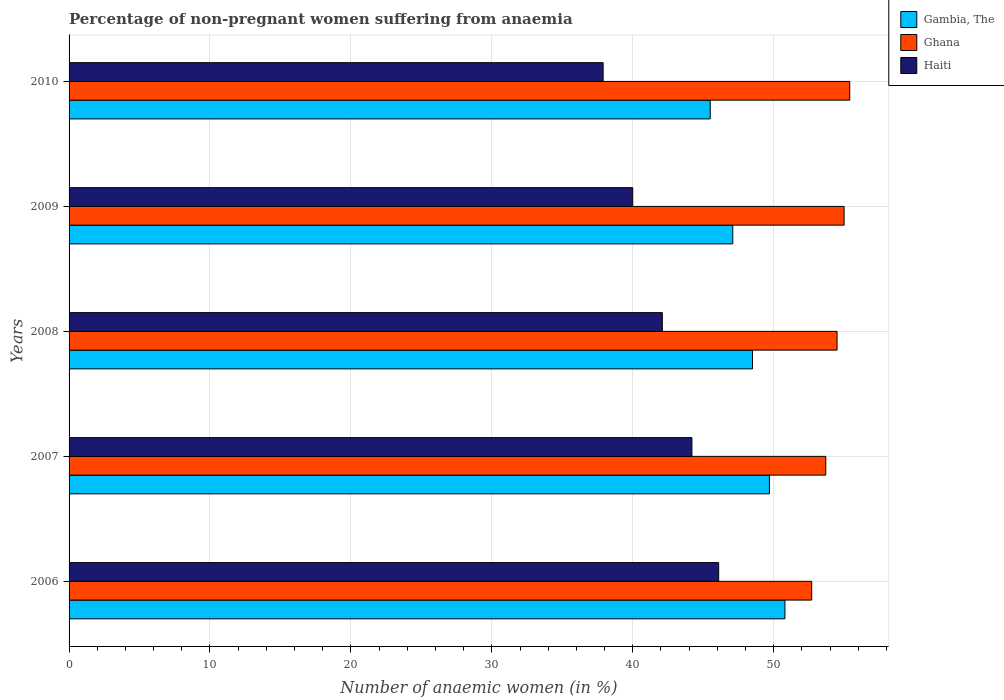How many groups of bars are there?
Ensure brevity in your answer.  5. How many bars are there on the 1st tick from the top?
Provide a succinct answer. 3. In how many cases, is the number of bars for a given year not equal to the number of legend labels?
Your answer should be compact. 0. What is the percentage of non-pregnant women suffering from anaemia in Gambia, The in 2007?
Provide a succinct answer. 49.7. Across all years, what is the maximum percentage of non-pregnant women suffering from anaemia in Gambia, The?
Keep it short and to the point. 50.8. Across all years, what is the minimum percentage of non-pregnant women suffering from anaemia in Ghana?
Provide a succinct answer. 52.7. In which year was the percentage of non-pregnant women suffering from anaemia in Ghana minimum?
Give a very brief answer. 2006. What is the total percentage of non-pregnant women suffering from anaemia in Haiti in the graph?
Offer a terse response. 210.3. What is the difference between the percentage of non-pregnant women suffering from anaemia in Haiti in 2008 and the percentage of non-pregnant women suffering from anaemia in Ghana in 2007?
Your answer should be very brief. -11.6. What is the average percentage of non-pregnant women suffering from anaemia in Gambia, The per year?
Give a very brief answer. 48.32. In the year 2006, what is the difference between the percentage of non-pregnant women suffering from anaemia in Ghana and percentage of non-pregnant women suffering from anaemia in Gambia, The?
Keep it short and to the point. 1.9. In how many years, is the percentage of non-pregnant women suffering from anaemia in Gambia, The greater than 12 %?
Keep it short and to the point. 5. What is the ratio of the percentage of non-pregnant women suffering from anaemia in Ghana in 2007 to that in 2008?
Keep it short and to the point. 0.99. Is the percentage of non-pregnant women suffering from anaemia in Ghana in 2009 less than that in 2010?
Your response must be concise. Yes. Is the difference between the percentage of non-pregnant women suffering from anaemia in Ghana in 2006 and 2007 greater than the difference between the percentage of non-pregnant women suffering from anaemia in Gambia, The in 2006 and 2007?
Keep it short and to the point. No. What is the difference between the highest and the second highest percentage of non-pregnant women suffering from anaemia in Ghana?
Ensure brevity in your answer.  0.4. What is the difference between the highest and the lowest percentage of non-pregnant women suffering from anaemia in Gambia, The?
Your answer should be compact. 5.3. What does the 3rd bar from the top in 2006 represents?
Your answer should be very brief. Gambia, The. What does the 2nd bar from the bottom in 2007 represents?
Your answer should be very brief. Ghana. Is it the case that in every year, the sum of the percentage of non-pregnant women suffering from anaemia in Ghana and percentage of non-pregnant women suffering from anaemia in Gambia, The is greater than the percentage of non-pregnant women suffering from anaemia in Haiti?
Ensure brevity in your answer.  Yes. How many years are there in the graph?
Make the answer very short. 5. Does the graph contain any zero values?
Your answer should be compact. No. Where does the legend appear in the graph?
Give a very brief answer. Top right. What is the title of the graph?
Ensure brevity in your answer.  Percentage of non-pregnant women suffering from anaemia. Does "Sub-Saharan Africa (developing only)" appear as one of the legend labels in the graph?
Provide a short and direct response. No. What is the label or title of the X-axis?
Your answer should be very brief. Number of anaemic women (in %). What is the label or title of the Y-axis?
Provide a short and direct response. Years. What is the Number of anaemic women (in %) in Gambia, The in 2006?
Your response must be concise. 50.8. What is the Number of anaemic women (in %) in Ghana in 2006?
Ensure brevity in your answer.  52.7. What is the Number of anaemic women (in %) of Haiti in 2006?
Provide a succinct answer. 46.1. What is the Number of anaemic women (in %) in Gambia, The in 2007?
Provide a short and direct response. 49.7. What is the Number of anaemic women (in %) in Ghana in 2007?
Your response must be concise. 53.7. What is the Number of anaemic women (in %) of Haiti in 2007?
Provide a succinct answer. 44.2. What is the Number of anaemic women (in %) in Gambia, The in 2008?
Your response must be concise. 48.5. What is the Number of anaemic women (in %) of Ghana in 2008?
Ensure brevity in your answer.  54.5. What is the Number of anaemic women (in %) of Haiti in 2008?
Your response must be concise. 42.1. What is the Number of anaemic women (in %) in Gambia, The in 2009?
Keep it short and to the point. 47.1. What is the Number of anaemic women (in %) in Ghana in 2009?
Ensure brevity in your answer.  55. What is the Number of anaemic women (in %) of Gambia, The in 2010?
Your response must be concise. 45.5. What is the Number of anaemic women (in %) in Ghana in 2010?
Give a very brief answer. 55.4. What is the Number of anaemic women (in %) in Haiti in 2010?
Your answer should be very brief. 37.9. Across all years, what is the maximum Number of anaemic women (in %) of Gambia, The?
Offer a very short reply. 50.8. Across all years, what is the maximum Number of anaemic women (in %) in Ghana?
Give a very brief answer. 55.4. Across all years, what is the maximum Number of anaemic women (in %) in Haiti?
Make the answer very short. 46.1. Across all years, what is the minimum Number of anaemic women (in %) in Gambia, The?
Provide a short and direct response. 45.5. Across all years, what is the minimum Number of anaemic women (in %) of Ghana?
Provide a succinct answer. 52.7. Across all years, what is the minimum Number of anaemic women (in %) of Haiti?
Provide a succinct answer. 37.9. What is the total Number of anaemic women (in %) of Gambia, The in the graph?
Provide a succinct answer. 241.6. What is the total Number of anaemic women (in %) of Ghana in the graph?
Offer a terse response. 271.3. What is the total Number of anaemic women (in %) in Haiti in the graph?
Offer a terse response. 210.3. What is the difference between the Number of anaemic women (in %) in Gambia, The in 2006 and that in 2007?
Make the answer very short. 1.1. What is the difference between the Number of anaemic women (in %) in Gambia, The in 2006 and that in 2008?
Keep it short and to the point. 2.3. What is the difference between the Number of anaemic women (in %) of Ghana in 2007 and that in 2008?
Offer a terse response. -0.8. What is the difference between the Number of anaemic women (in %) of Gambia, The in 2007 and that in 2009?
Keep it short and to the point. 2.6. What is the difference between the Number of anaemic women (in %) in Gambia, The in 2007 and that in 2010?
Offer a terse response. 4.2. What is the difference between the Number of anaemic women (in %) in Ghana in 2007 and that in 2010?
Keep it short and to the point. -1.7. What is the difference between the Number of anaemic women (in %) of Ghana in 2008 and that in 2010?
Make the answer very short. -0.9. What is the difference between the Number of anaemic women (in %) of Gambia, The in 2009 and that in 2010?
Keep it short and to the point. 1.6. What is the difference between the Number of anaemic women (in %) of Gambia, The in 2006 and the Number of anaemic women (in %) of Haiti in 2007?
Give a very brief answer. 6.6. What is the difference between the Number of anaemic women (in %) in Ghana in 2006 and the Number of anaemic women (in %) in Haiti in 2007?
Provide a succinct answer. 8.5. What is the difference between the Number of anaemic women (in %) in Gambia, The in 2006 and the Number of anaemic women (in %) in Haiti in 2008?
Provide a short and direct response. 8.7. What is the difference between the Number of anaemic women (in %) of Gambia, The in 2006 and the Number of anaemic women (in %) of Ghana in 2010?
Your response must be concise. -4.6. What is the difference between the Number of anaemic women (in %) of Gambia, The in 2006 and the Number of anaemic women (in %) of Haiti in 2010?
Ensure brevity in your answer.  12.9. What is the difference between the Number of anaemic women (in %) in Ghana in 2006 and the Number of anaemic women (in %) in Haiti in 2010?
Ensure brevity in your answer.  14.8. What is the difference between the Number of anaemic women (in %) of Gambia, The in 2007 and the Number of anaemic women (in %) of Ghana in 2008?
Give a very brief answer. -4.8. What is the difference between the Number of anaemic women (in %) of Gambia, The in 2007 and the Number of anaemic women (in %) of Ghana in 2009?
Offer a very short reply. -5.3. What is the difference between the Number of anaemic women (in %) in Gambia, The in 2007 and the Number of anaemic women (in %) in Ghana in 2010?
Give a very brief answer. -5.7. What is the difference between the Number of anaemic women (in %) in Gambia, The in 2008 and the Number of anaemic women (in %) in Haiti in 2010?
Keep it short and to the point. 10.6. What is the difference between the Number of anaemic women (in %) of Ghana in 2009 and the Number of anaemic women (in %) of Haiti in 2010?
Offer a very short reply. 17.1. What is the average Number of anaemic women (in %) in Gambia, The per year?
Ensure brevity in your answer.  48.32. What is the average Number of anaemic women (in %) of Ghana per year?
Your answer should be very brief. 54.26. What is the average Number of anaemic women (in %) of Haiti per year?
Ensure brevity in your answer.  42.06. In the year 2007, what is the difference between the Number of anaemic women (in %) of Gambia, The and Number of anaemic women (in %) of Haiti?
Offer a terse response. 5.5. In the year 2007, what is the difference between the Number of anaemic women (in %) of Ghana and Number of anaemic women (in %) of Haiti?
Your answer should be very brief. 9.5. In the year 2008, what is the difference between the Number of anaemic women (in %) of Ghana and Number of anaemic women (in %) of Haiti?
Offer a terse response. 12.4. In the year 2010, what is the difference between the Number of anaemic women (in %) in Gambia, The and Number of anaemic women (in %) in Ghana?
Offer a very short reply. -9.9. In the year 2010, what is the difference between the Number of anaemic women (in %) of Ghana and Number of anaemic women (in %) of Haiti?
Offer a terse response. 17.5. What is the ratio of the Number of anaemic women (in %) of Gambia, The in 2006 to that in 2007?
Provide a short and direct response. 1.02. What is the ratio of the Number of anaemic women (in %) of Ghana in 2006 to that in 2007?
Make the answer very short. 0.98. What is the ratio of the Number of anaemic women (in %) of Haiti in 2006 to that in 2007?
Give a very brief answer. 1.04. What is the ratio of the Number of anaemic women (in %) of Gambia, The in 2006 to that in 2008?
Your response must be concise. 1.05. What is the ratio of the Number of anaemic women (in %) in Ghana in 2006 to that in 2008?
Give a very brief answer. 0.97. What is the ratio of the Number of anaemic women (in %) of Haiti in 2006 to that in 2008?
Give a very brief answer. 1.09. What is the ratio of the Number of anaemic women (in %) in Gambia, The in 2006 to that in 2009?
Your response must be concise. 1.08. What is the ratio of the Number of anaemic women (in %) of Ghana in 2006 to that in 2009?
Make the answer very short. 0.96. What is the ratio of the Number of anaemic women (in %) of Haiti in 2006 to that in 2009?
Your response must be concise. 1.15. What is the ratio of the Number of anaemic women (in %) in Gambia, The in 2006 to that in 2010?
Give a very brief answer. 1.12. What is the ratio of the Number of anaemic women (in %) of Ghana in 2006 to that in 2010?
Your answer should be compact. 0.95. What is the ratio of the Number of anaemic women (in %) in Haiti in 2006 to that in 2010?
Offer a very short reply. 1.22. What is the ratio of the Number of anaemic women (in %) in Gambia, The in 2007 to that in 2008?
Your answer should be very brief. 1.02. What is the ratio of the Number of anaemic women (in %) in Ghana in 2007 to that in 2008?
Ensure brevity in your answer.  0.99. What is the ratio of the Number of anaemic women (in %) in Haiti in 2007 to that in 2008?
Your response must be concise. 1.05. What is the ratio of the Number of anaemic women (in %) of Gambia, The in 2007 to that in 2009?
Your response must be concise. 1.06. What is the ratio of the Number of anaemic women (in %) in Ghana in 2007 to that in 2009?
Your answer should be very brief. 0.98. What is the ratio of the Number of anaemic women (in %) of Haiti in 2007 to that in 2009?
Provide a short and direct response. 1.1. What is the ratio of the Number of anaemic women (in %) of Gambia, The in 2007 to that in 2010?
Offer a terse response. 1.09. What is the ratio of the Number of anaemic women (in %) in Ghana in 2007 to that in 2010?
Ensure brevity in your answer.  0.97. What is the ratio of the Number of anaemic women (in %) in Haiti in 2007 to that in 2010?
Provide a short and direct response. 1.17. What is the ratio of the Number of anaemic women (in %) of Gambia, The in 2008 to that in 2009?
Your answer should be very brief. 1.03. What is the ratio of the Number of anaemic women (in %) of Ghana in 2008 to that in 2009?
Ensure brevity in your answer.  0.99. What is the ratio of the Number of anaemic women (in %) in Haiti in 2008 to that in 2009?
Provide a succinct answer. 1.05. What is the ratio of the Number of anaemic women (in %) in Gambia, The in 2008 to that in 2010?
Provide a succinct answer. 1.07. What is the ratio of the Number of anaemic women (in %) of Ghana in 2008 to that in 2010?
Keep it short and to the point. 0.98. What is the ratio of the Number of anaemic women (in %) of Haiti in 2008 to that in 2010?
Offer a terse response. 1.11. What is the ratio of the Number of anaemic women (in %) of Gambia, The in 2009 to that in 2010?
Ensure brevity in your answer.  1.04. What is the ratio of the Number of anaemic women (in %) of Haiti in 2009 to that in 2010?
Provide a short and direct response. 1.06. What is the difference between the highest and the lowest Number of anaemic women (in %) in Gambia, The?
Keep it short and to the point. 5.3. What is the difference between the highest and the lowest Number of anaemic women (in %) in Ghana?
Provide a succinct answer. 2.7. What is the difference between the highest and the lowest Number of anaemic women (in %) in Haiti?
Give a very brief answer. 8.2. 